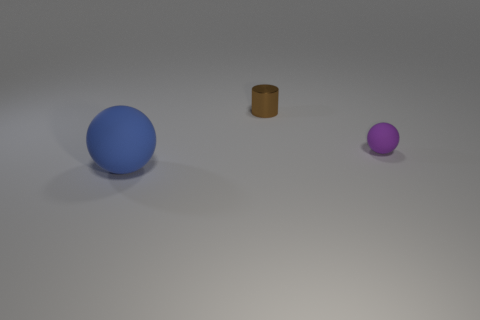What is the small purple thing made of?
Ensure brevity in your answer.  Rubber. The big thing has what color?
Your answer should be compact. Blue. There is a thing that is both to the right of the large blue matte ball and in front of the brown object; what color is it?
Make the answer very short. Purple. Is there anything else that is the same material as the tiny cylinder?
Provide a short and direct response. No. Is the tiny sphere made of the same material as the small thing left of the purple thing?
Keep it short and to the point. No. There is a blue object on the left side of the rubber sphere to the right of the blue rubber thing; how big is it?
Your answer should be very brief. Large. Are there any other things that have the same color as the tiny metal object?
Your response must be concise. No. Do the tiny object behind the small ball and the ball that is in front of the purple matte object have the same material?
Offer a terse response. No. There is a object that is left of the tiny purple rubber ball and to the right of the large blue thing; what is it made of?
Provide a succinct answer. Metal. There is a big blue object; is it the same shape as the small thing that is on the left side of the purple matte ball?
Ensure brevity in your answer.  No. 